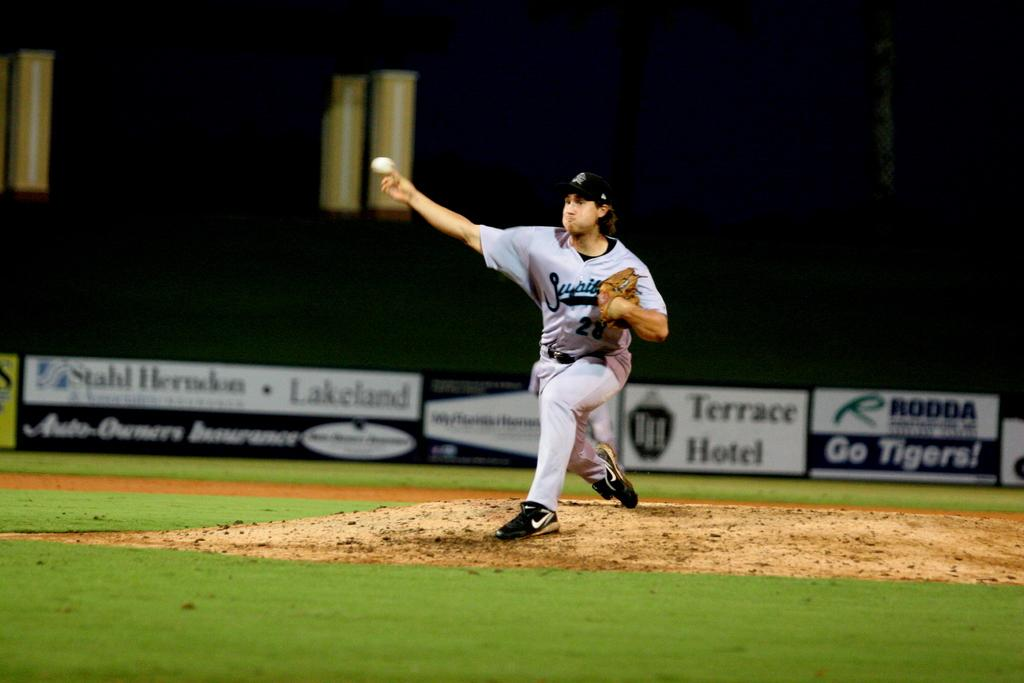<image>
Offer a succinct explanation of the picture presented. a player pitching with a Terrace Hotel sign behind him 